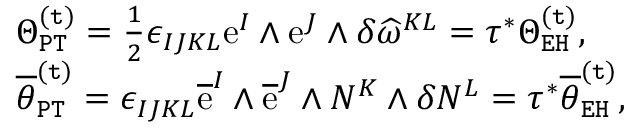<formula> <loc_0><loc_0><loc_500><loc_500>\begin{array} { r l } & { \Theta _ { P T } ^ { ( t ) } = \frac { 1 } { 2 } \epsilon _ { I J K L } e ^ { I } \wedge e ^ { J } \wedge \delta \widehat { \omega } ^ { K L } = \tau ^ { * } \Theta _ { E H } ^ { ( t ) } , } \\ & { \overline { \theta } _ { P T } ^ { ( t ) } = \epsilon _ { I J K L } \overline { e } ^ { I } \wedge \overline { e } ^ { J } \wedge N ^ { K } \wedge \delta N ^ { L } = \tau ^ { * } \overline { \theta } _ { E H } ^ { ( t ) } , } \end{array}</formula> 